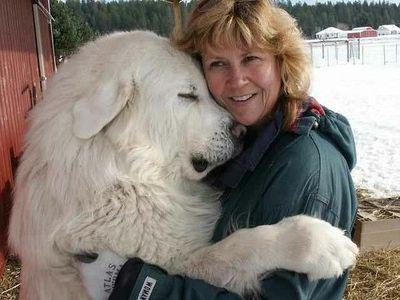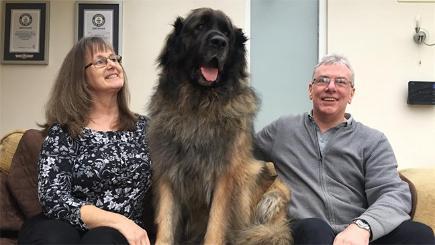The first image is the image on the left, the second image is the image on the right. Assess this claim about the two images: "Dog sits with humans on a couch.". Correct or not? Answer yes or no. Yes. 